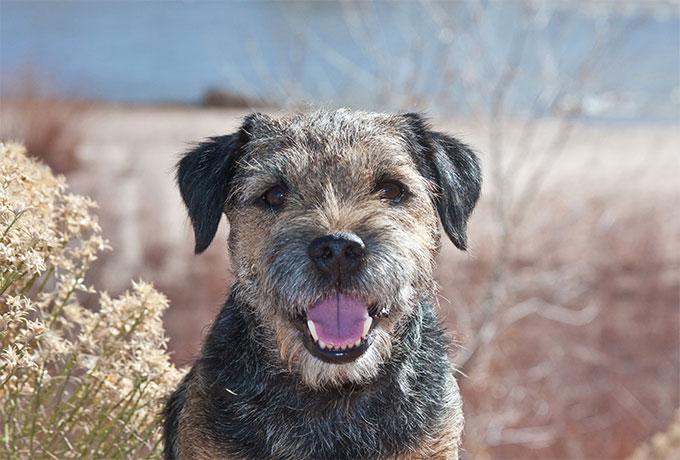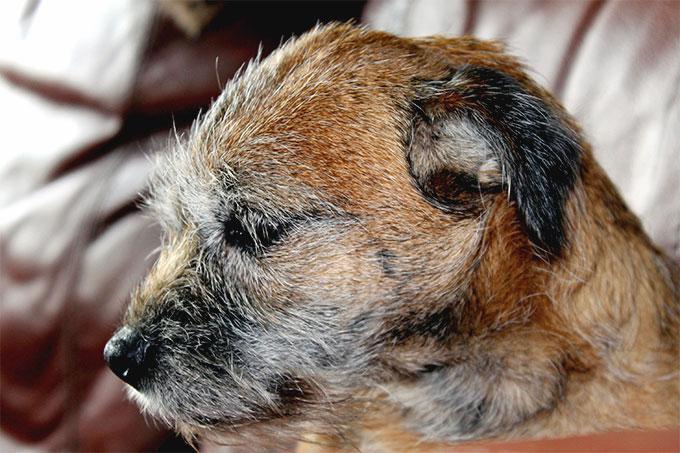The first image is the image on the left, the second image is the image on the right. Analyze the images presented: Is the assertion "An image shows one dog facing the camera directly, with mouth open." valid? Answer yes or no. Yes. The first image is the image on the left, the second image is the image on the right. Considering the images on both sides, is "brightly colored collars are visible" valid? Answer yes or no. No. 